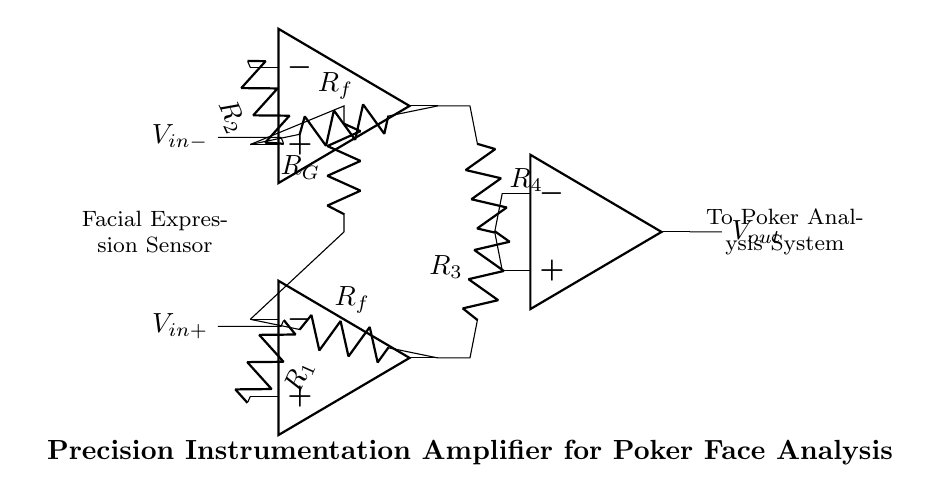What is the type of amplifier used in this circuit? The circuit diagram features three operational amplifiers arranged in a specific configuration, which is characteristic of instrumentation amplifiers.
Answer: instrumentation amplifier What are the resistor values labeled in the circuit? The circuit references resistors \(R_1\), \(R_2\), \(R_f\), \(R_G\), \(R_3\), and \(R_4\), distributed across the input and feedback paths, critical for the gain calculation and performance of the amplifier.
Answer: R1, R2, Rf, RG, R3, R4 How many operational amplifiers are used in this circuit? A careful examination of the circuit shows three distinct operational amplifiers, which are fundamental to the design of this precision instrumentation amplifier.
Answer: three What is the purpose of the resistors labeled \(R_f\)? The feedback resistors \(R_f\) provide feedback from the output back to the input of each operational amplifier, which is essential for controlling the gain of the amplifier and optimizing its performance.
Answer: feedback control How do the input signals \(V_{in+}\) and \(V_{in-}\) interact in this circuit? The signals \(V_{in+}\) and \(V_{in-}\) are fed into different amplifiers, allowing for the differential input to be amplified while minimizing common-mode noise, which is crucial for detecting subtle changes in facial expressions.
Answer: differential input amplification What is the output voltage representation in this circuit? The output voltage, labeled as \(V_{out}\), represents the amplified difference between the input signals and is the final output of the instrumentation amplifier, sent to the poker analysis system.
Answer: Vout 